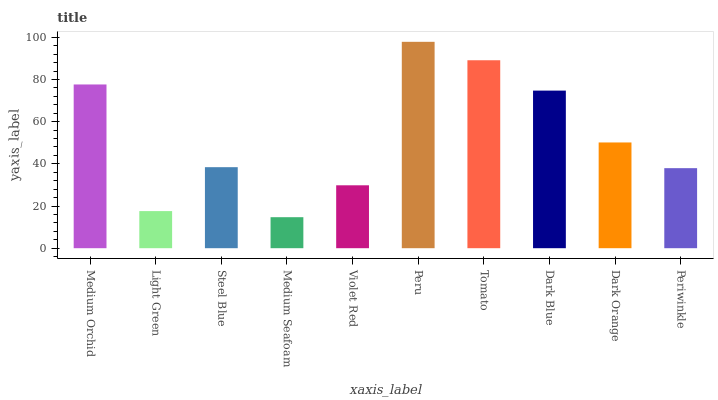Is Medium Seafoam the minimum?
Answer yes or no. Yes. Is Peru the maximum?
Answer yes or no. Yes. Is Light Green the minimum?
Answer yes or no. No. Is Light Green the maximum?
Answer yes or no. No. Is Medium Orchid greater than Light Green?
Answer yes or no. Yes. Is Light Green less than Medium Orchid?
Answer yes or no. Yes. Is Light Green greater than Medium Orchid?
Answer yes or no. No. Is Medium Orchid less than Light Green?
Answer yes or no. No. Is Dark Orange the high median?
Answer yes or no. Yes. Is Steel Blue the low median?
Answer yes or no. Yes. Is Violet Red the high median?
Answer yes or no. No. Is Medium Seafoam the low median?
Answer yes or no. No. 